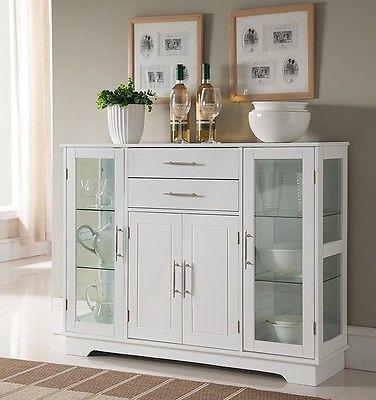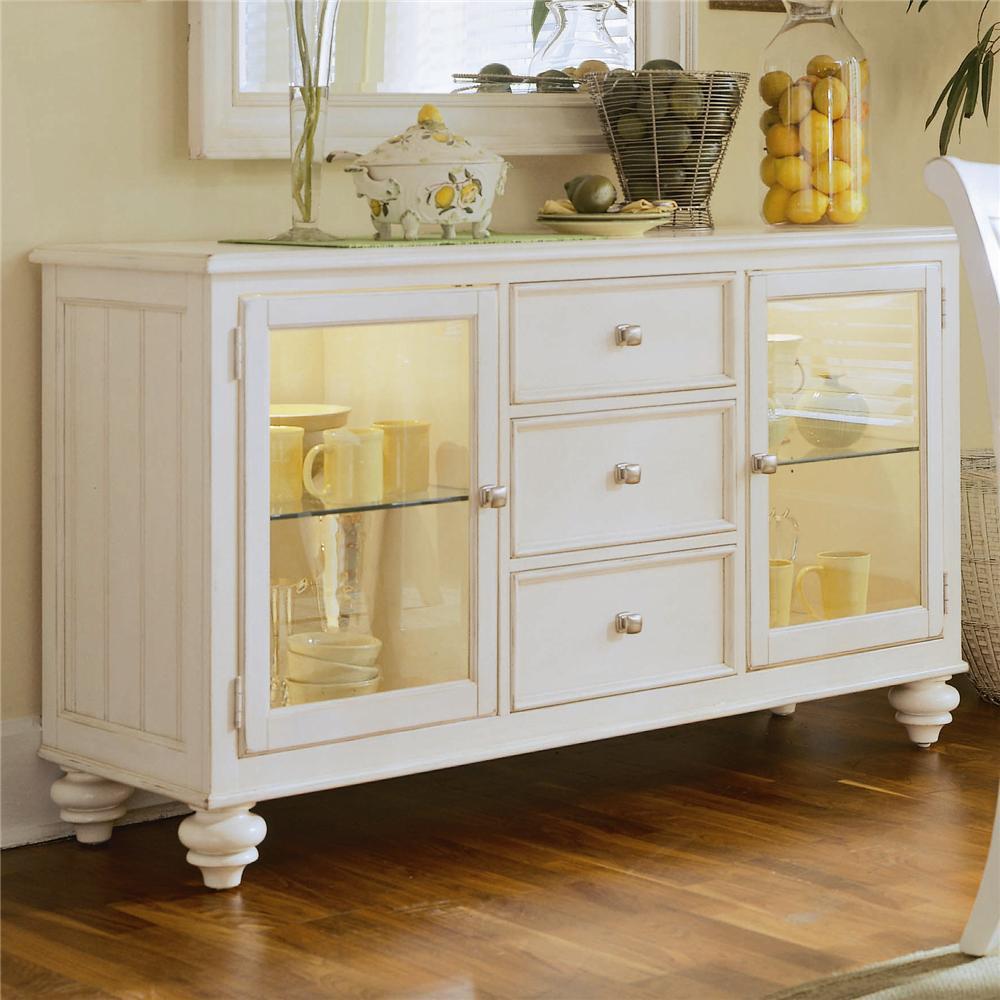The first image is the image on the left, the second image is the image on the right. Given the left and right images, does the statement "The white cabinet on the left has an ornate, curved top piece" hold true? Answer yes or no. No. The first image is the image on the left, the second image is the image on the right. For the images shown, is this caption "The top of one cabinet is not flat, and features two curl shapes that face each other." true? Answer yes or no. No. 